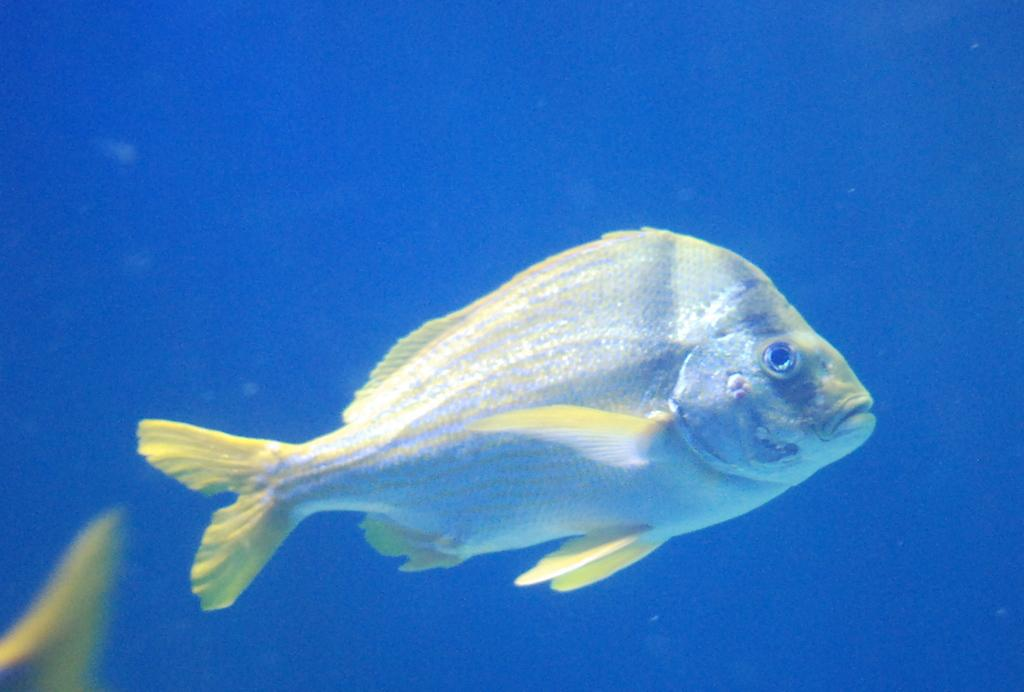What type of animal is in the image? There is a fish in the image. Where is the fish located? The fish is in the water. What type of powder is being used to clean the fish in the image? There is no powder or cleaning activity present in the image; it simply shows a fish in the water. 